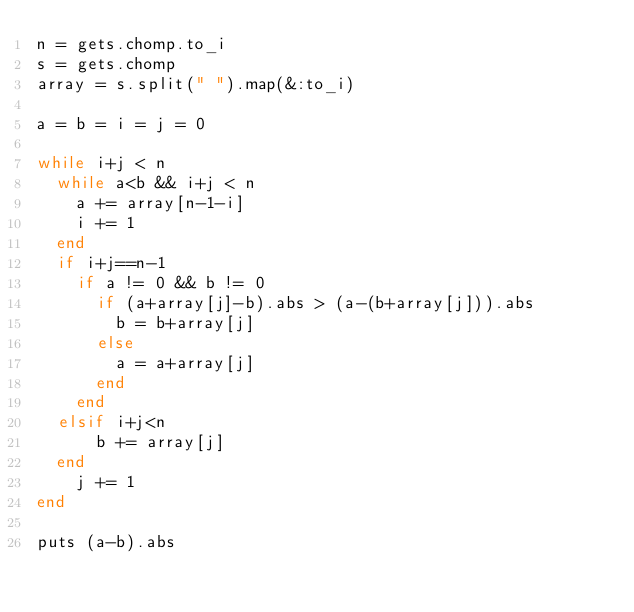Convert code to text. <code><loc_0><loc_0><loc_500><loc_500><_Ruby_>n = gets.chomp.to_i
s = gets.chomp
array = s.split(" ").map(&:to_i)

a = b = i = j = 0

while i+j < n
  while a<b && i+j < n
    a += array[n-1-i]
    i += 1
  end
  if i+j==n-1
    if a != 0 && b != 0
      if (a+array[j]-b).abs > (a-(b+array[j])).abs
        b = b+array[j]
      else
        a = a+array[j]
      end
    end
  elsif i+j<n
      b += array[j]
  end
    j += 1
end

puts (a-b).abs
</code> 